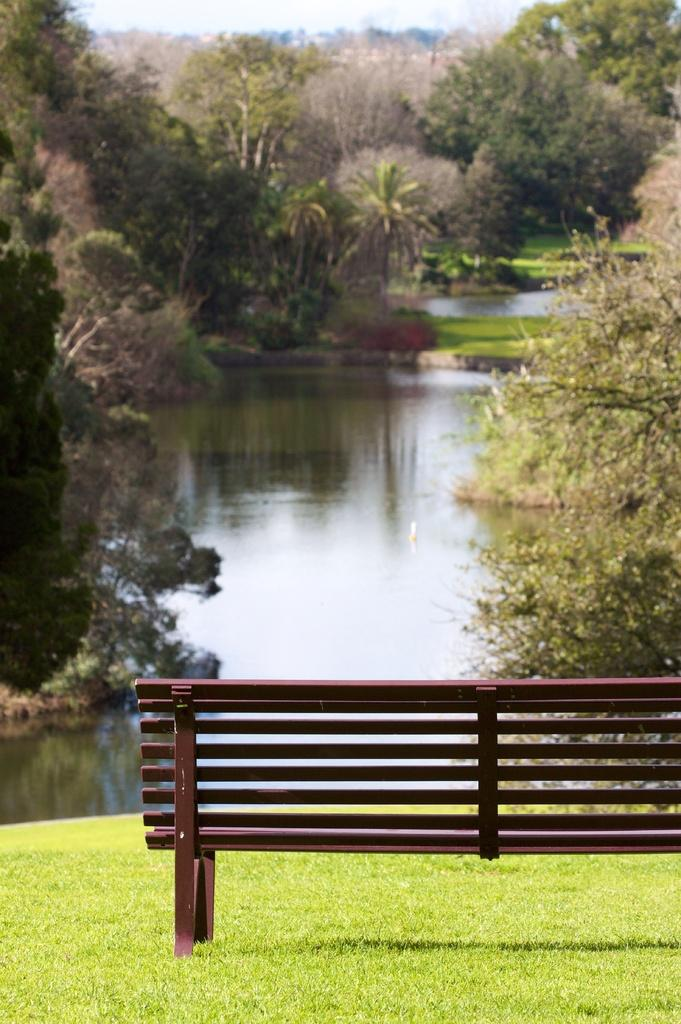What type of seating is visible in the image? There is a bench in the image. Where is the bench located? The bench is on grass land. What is in front of the bench? There is a lake in front of the bench. What type of vegetation is present near the bench? Trees are present on either side of the bench. What can be seen above the bench? The sky is visible above the bench. What type of neck treatment is being performed on the bench in the image? There is no neck treatment being performed in the image; it only features a bench, grass land, a lake, trees, and the sky. 